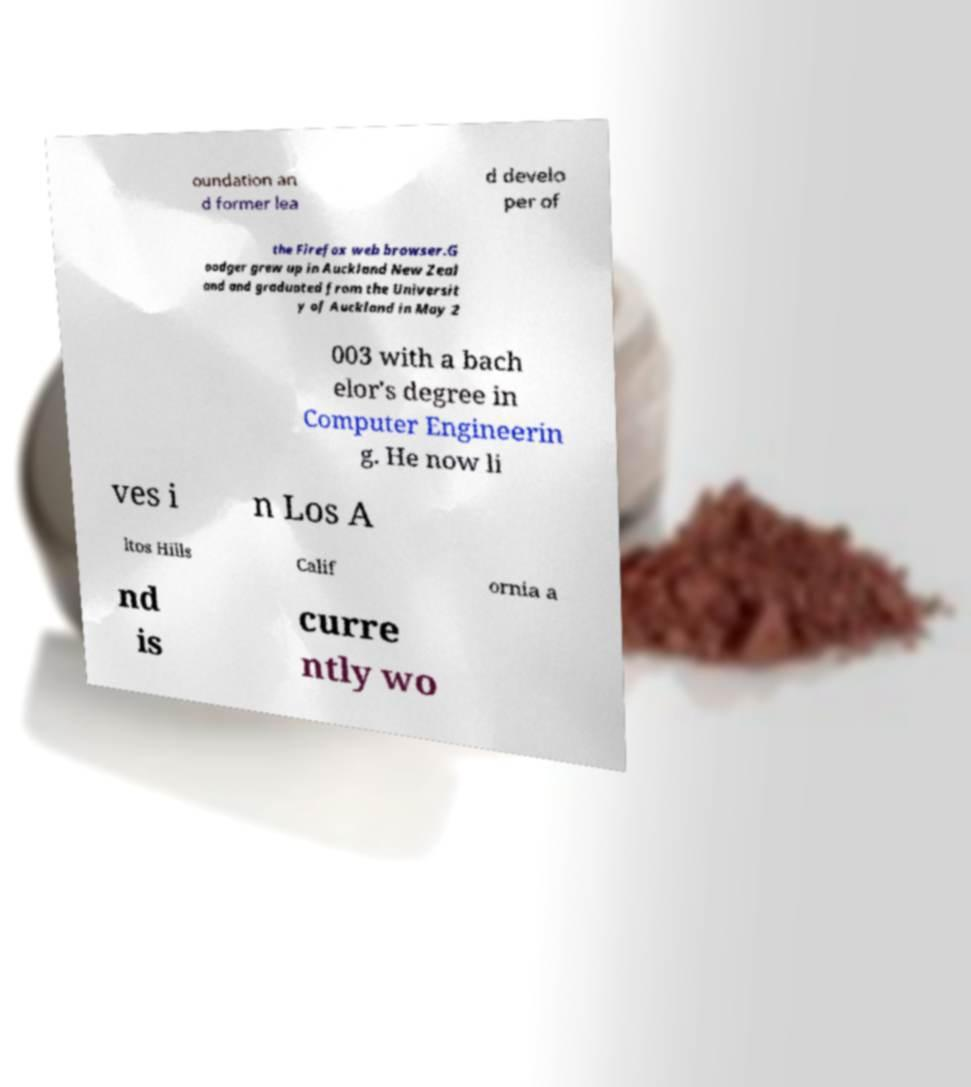Could you assist in decoding the text presented in this image and type it out clearly? oundation an d former lea d develo per of the Firefox web browser.G oodger grew up in Auckland New Zeal and and graduated from the Universit y of Auckland in May 2 003 with a bach elor's degree in Computer Engineerin g. He now li ves i n Los A ltos Hills Calif ornia a nd is curre ntly wo 